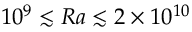<formula> <loc_0><loc_0><loc_500><loc_500>1 0 ^ { 9 } \lesssim R a \lesssim 2 \times 1 0 ^ { 1 0 }</formula> 